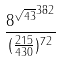<formula> <loc_0><loc_0><loc_500><loc_500>\frac { { 8 ^ { \sqrt { 4 3 } } } ^ { 3 8 2 } } { ( \frac { 2 1 5 } { 4 3 0 } ) ^ { 7 2 } }</formula> 